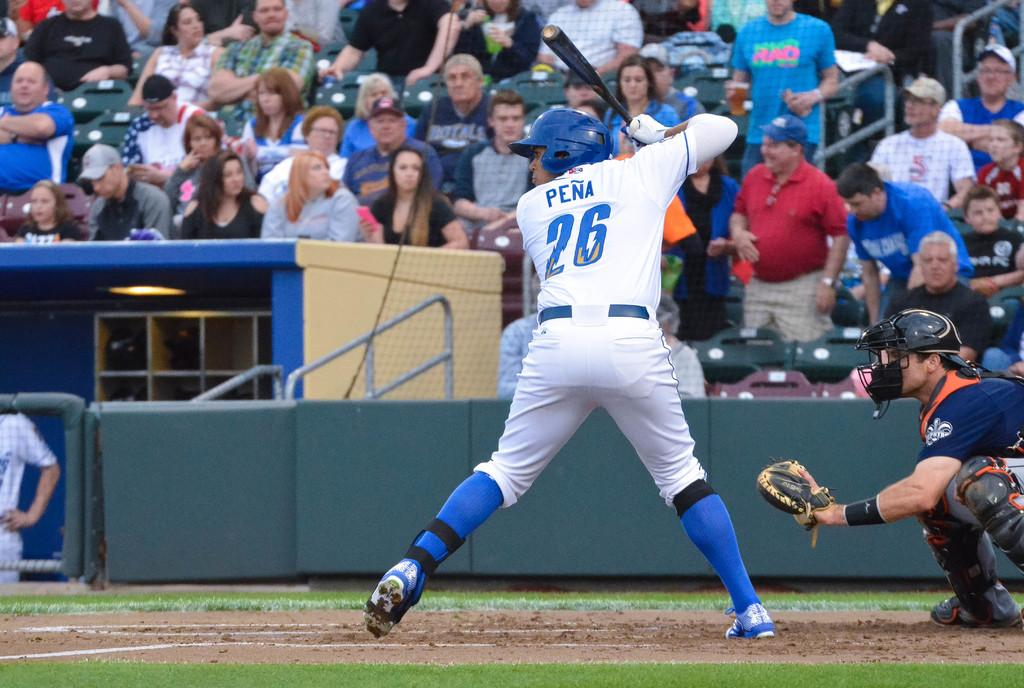<image>
Render a clear and concise summary of the photo. The batter has on a Pena 26 shirt. 